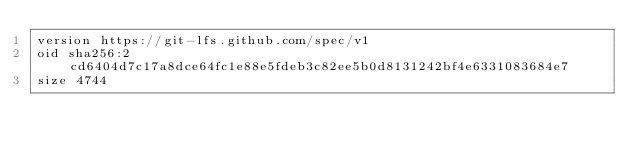<code> <loc_0><loc_0><loc_500><loc_500><_SQL_>version https://git-lfs.github.com/spec/v1
oid sha256:2cd6404d7c17a8dce64fc1e88e5fdeb3c82ee5b0d8131242bf4e6331083684e7
size 4744
</code> 